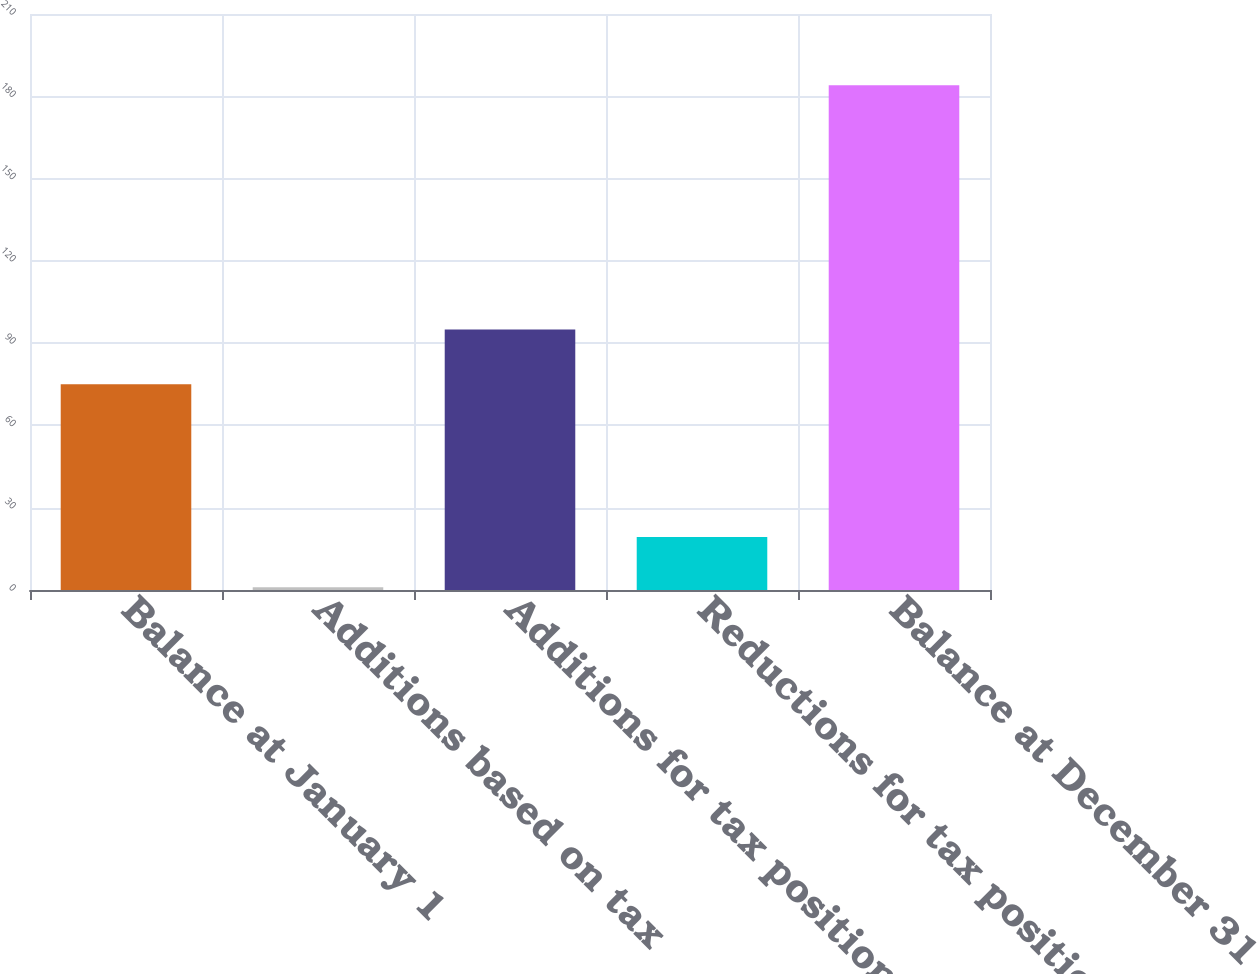<chart> <loc_0><loc_0><loc_500><loc_500><bar_chart><fcel>Balance at January 1<fcel>Additions based on tax<fcel>Additions for tax positions of<fcel>Reductions for tax positions<fcel>Balance at December 31<nl><fcel>75<fcel>1<fcel>95<fcel>19.3<fcel>184<nl></chart> 